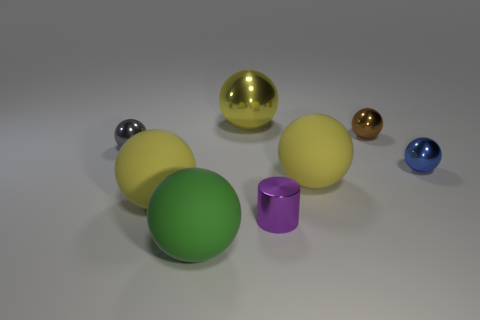There is a matte object right of the large yellow metallic thing; is it the same color as the big metallic ball?
Your answer should be compact. Yes. How many other objects are the same material as the small cylinder?
Offer a very short reply. 4. What number of purple metallic cylinders are behind the tiny thing that is on the left side of the large metal sphere?
Your answer should be compact. 0. Is there any other thing that is the same shape as the purple shiny object?
Give a very brief answer. No. Is the color of the big thing that is behind the tiny blue thing the same as the big rubber object that is right of the tiny purple cylinder?
Keep it short and to the point. Yes. Is the number of big yellow shiny things less than the number of things?
Give a very brief answer. Yes. The small metallic object that is in front of the large yellow rubber thing to the right of the small purple cylinder is what shape?
Your answer should be compact. Cylinder. What is the shape of the small shiny thing that is in front of the large yellow thing in front of the large ball right of the yellow shiny object?
Offer a terse response. Cylinder. How many objects are either shiny things in front of the tiny brown metal thing or yellow things that are right of the tiny purple shiny cylinder?
Offer a terse response. 4. There is a green object; does it have the same size as the thing that is to the right of the small brown ball?
Your response must be concise. No. 